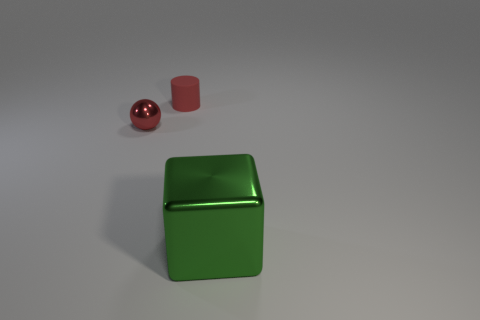Add 1 blue shiny spheres. How many objects exist? 4 Subtract all spheres. How many objects are left? 2 Subtract 0 cyan balls. How many objects are left? 3 Subtract all large cyan matte spheres. Subtract all red things. How many objects are left? 1 Add 2 tiny red rubber objects. How many tiny red rubber objects are left? 3 Add 3 tiny blue metallic blocks. How many tiny blue metallic blocks exist? 3 